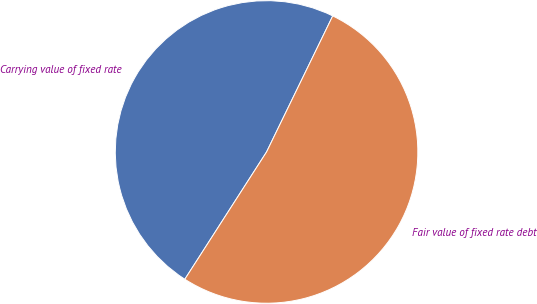<chart> <loc_0><loc_0><loc_500><loc_500><pie_chart><fcel>Carrying value of fixed rate<fcel>Fair value of fixed rate debt<nl><fcel>48.12%<fcel>51.88%<nl></chart> 